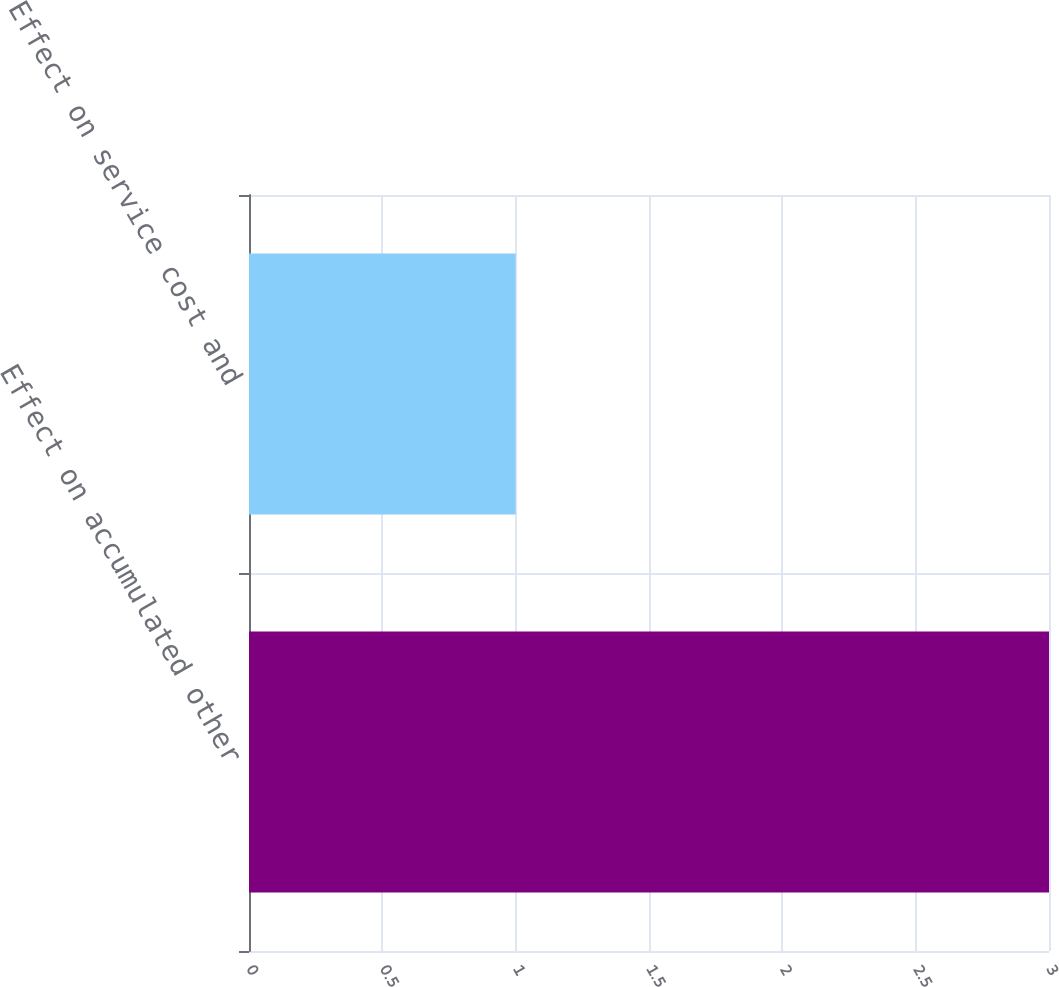Convert chart to OTSL. <chart><loc_0><loc_0><loc_500><loc_500><bar_chart><fcel>Effect on accumulated other<fcel>Effect on service cost and<nl><fcel>3<fcel>1<nl></chart> 